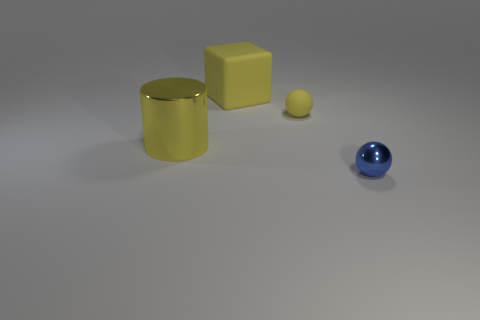Add 4 big brown things. How many objects exist? 8 Subtract all blocks. How many objects are left? 3 Add 1 blue metallic objects. How many blue metallic objects exist? 2 Subtract 0 purple balls. How many objects are left? 4 Subtract all green cylinders. Subtract all yellow objects. How many objects are left? 1 Add 4 big yellow cubes. How many big yellow cubes are left? 5 